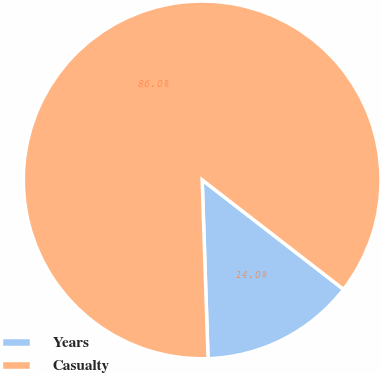Convert chart. <chart><loc_0><loc_0><loc_500><loc_500><pie_chart><fcel>Years<fcel>Casualty<nl><fcel>13.99%<fcel>86.01%<nl></chart> 